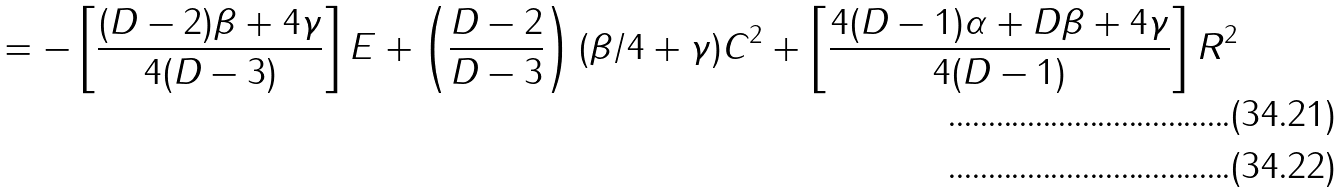Convert formula to latex. <formula><loc_0><loc_0><loc_500><loc_500>= - \left [ \frac { ( D - 2 ) \beta + 4 \gamma } { 4 ( D - 3 ) } \right ] E + \left ( \frac { D - 2 } { D - 3 } \right ) ( \beta / 4 + \gamma ) C ^ { 2 } + \left [ \frac { 4 ( D - 1 ) \alpha + D \beta + 4 \gamma } { 4 ( D - 1 ) } \right ] R ^ { 2 } \\</formula> 